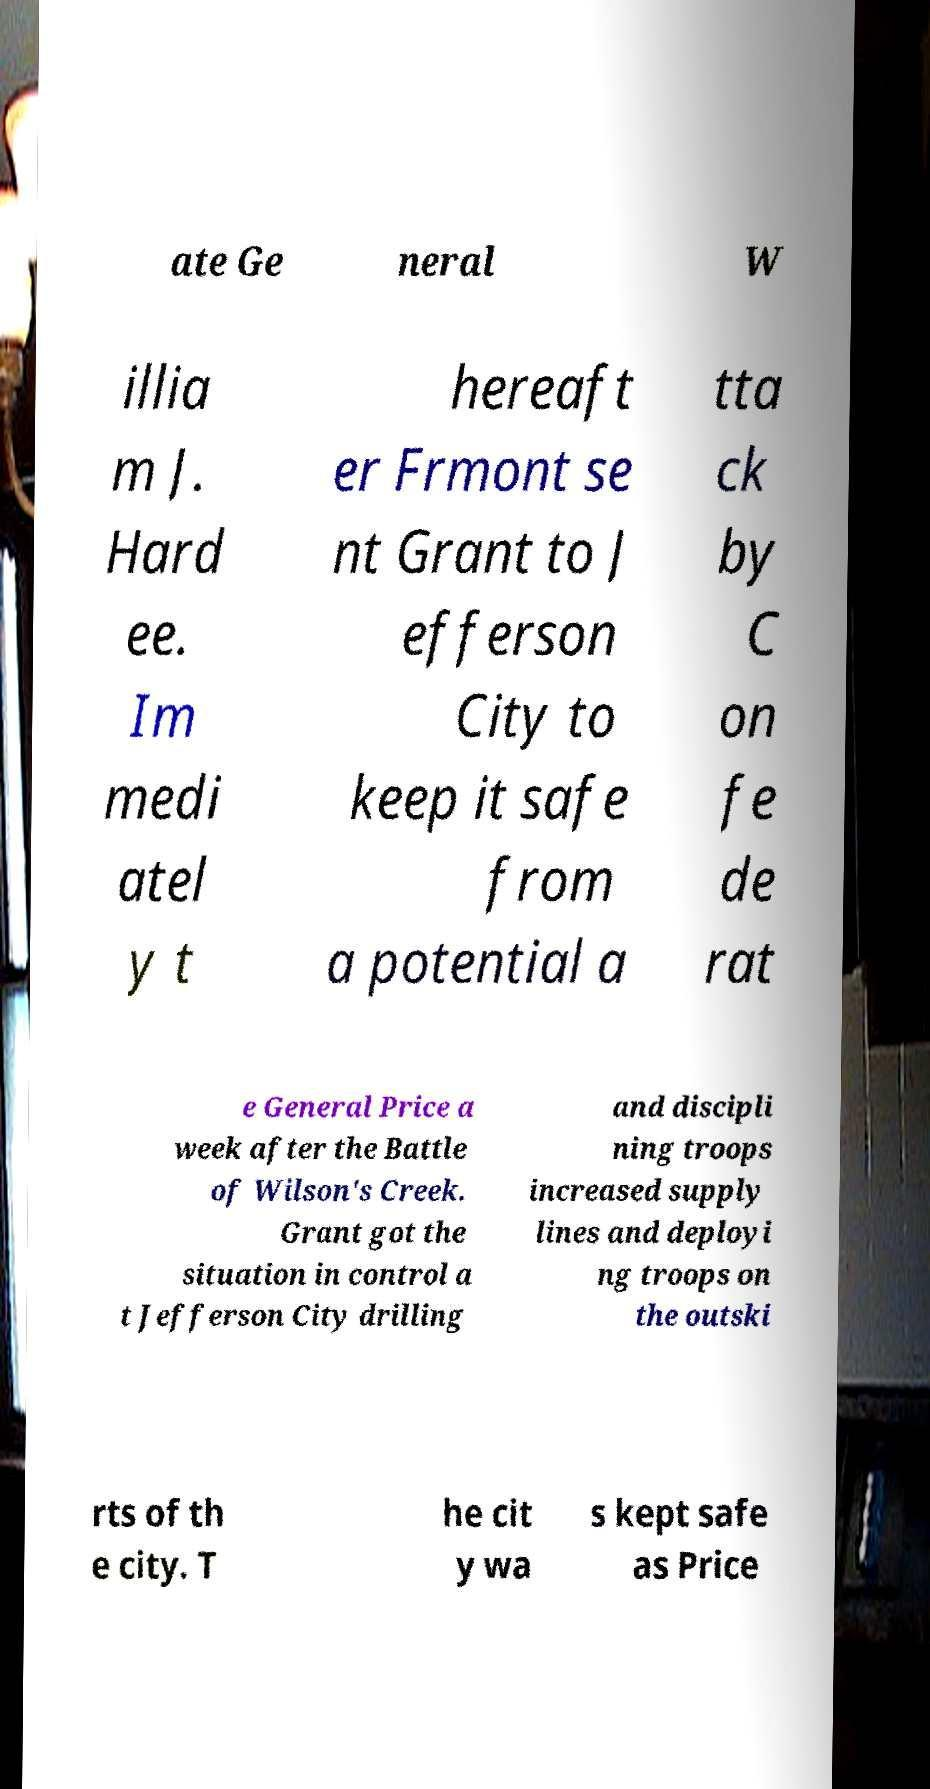Please identify and transcribe the text found in this image. ate Ge neral W illia m J. Hard ee. Im medi atel y t hereaft er Frmont se nt Grant to J efferson City to keep it safe from a potential a tta ck by C on fe de rat e General Price a week after the Battle of Wilson's Creek. Grant got the situation in control a t Jefferson City drilling and discipli ning troops increased supply lines and deployi ng troops on the outski rts of th e city. T he cit y wa s kept safe as Price 